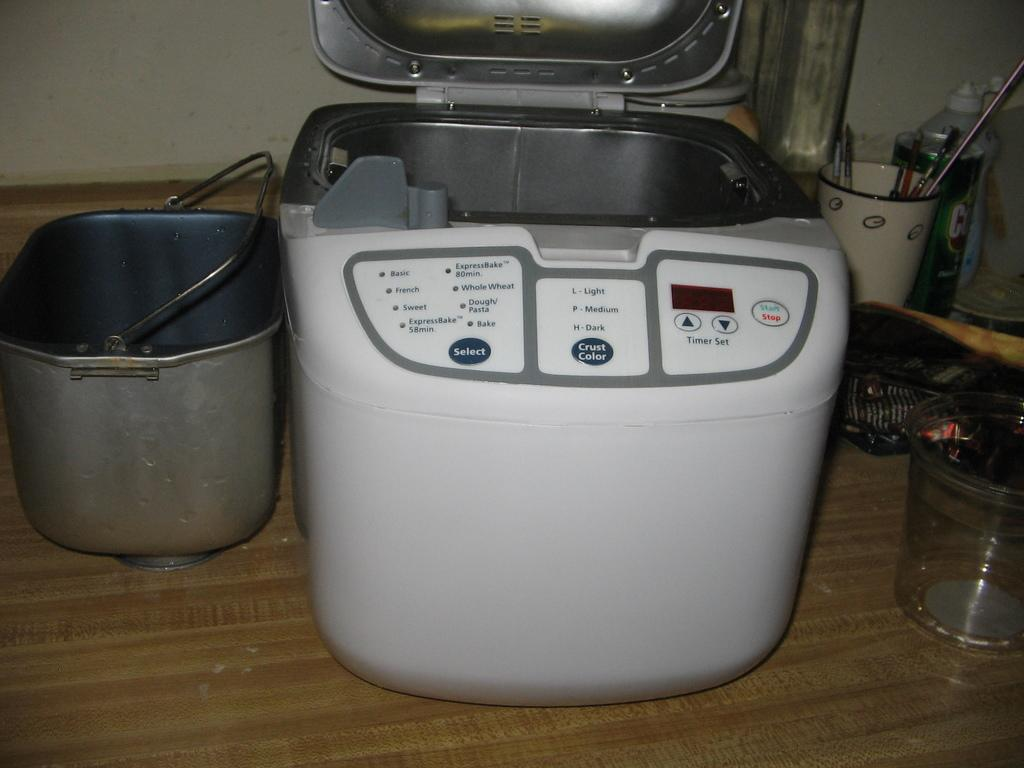<image>
Relay a brief, clear account of the picture shown. A bread machine has different types of crust colors available such as light, medium and dark 